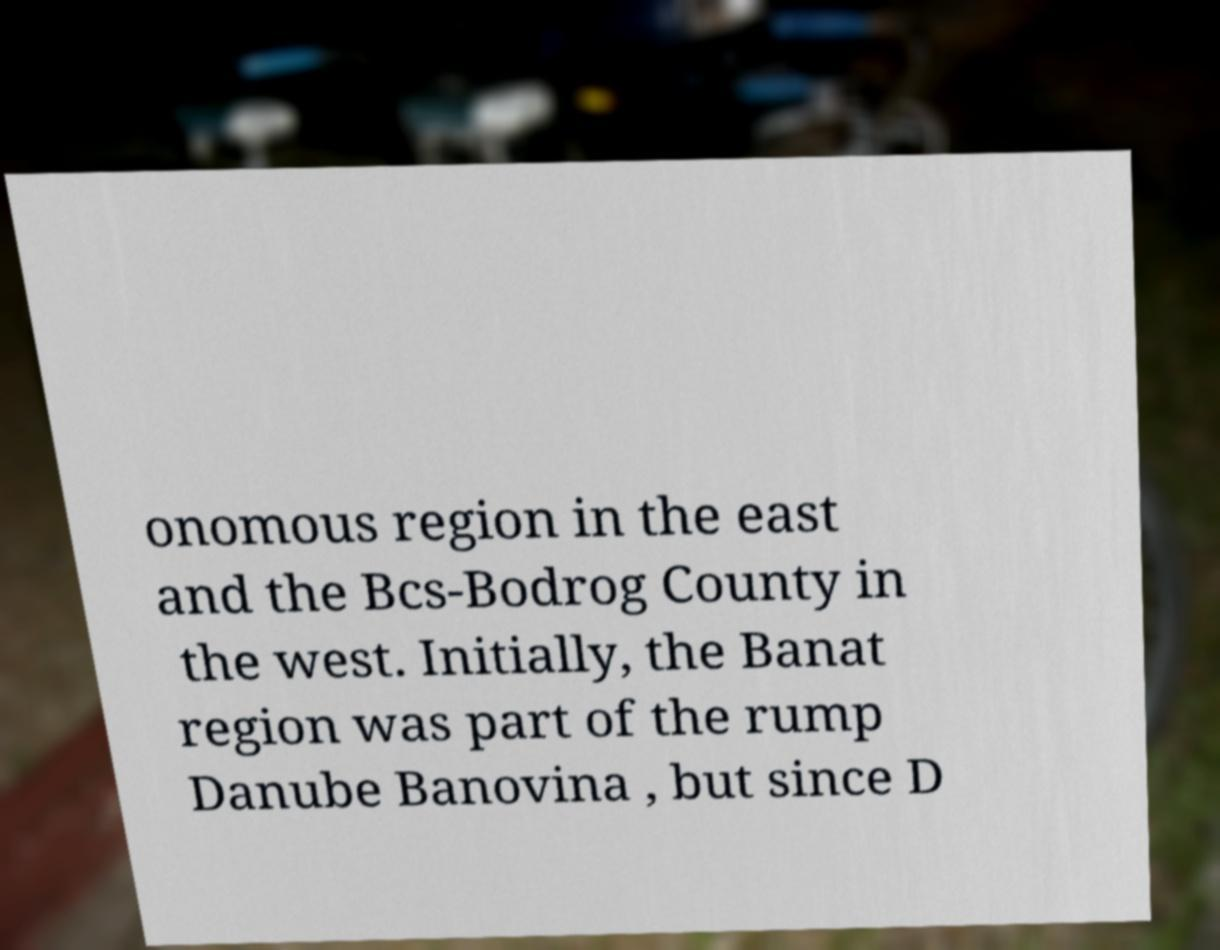Could you extract and type out the text from this image? onomous region in the east and the Bcs-Bodrog County in the west. Initially, the Banat region was part of the rump Danube Banovina , but since D 